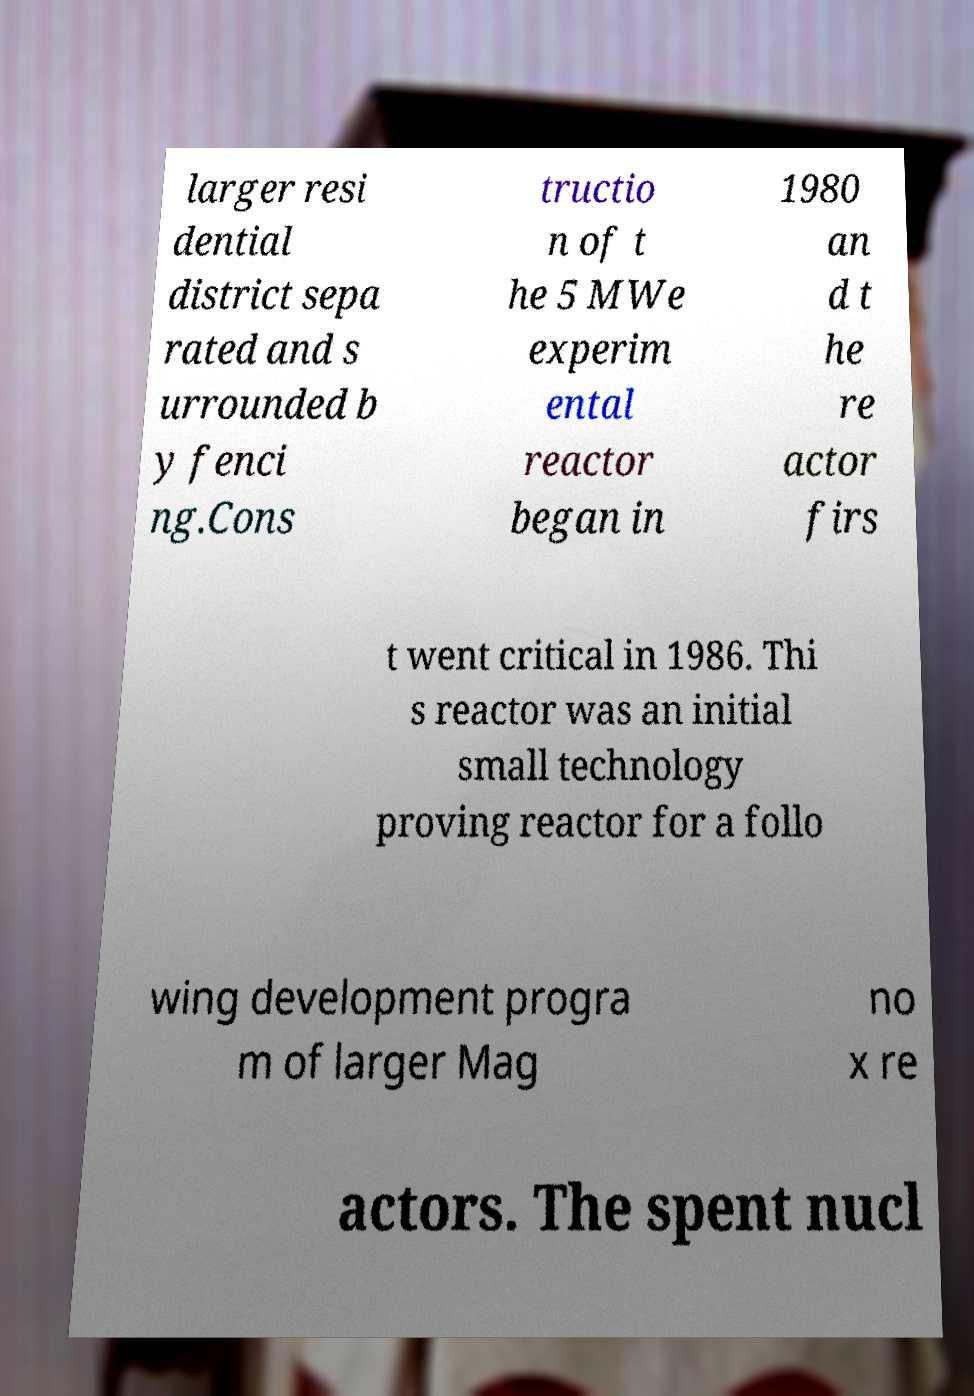Can you read and provide the text displayed in the image?This photo seems to have some interesting text. Can you extract and type it out for me? larger resi dential district sepa rated and s urrounded b y fenci ng.Cons tructio n of t he 5 MWe experim ental reactor began in 1980 an d t he re actor firs t went critical in 1986. Thi s reactor was an initial small technology proving reactor for a follo wing development progra m of larger Mag no x re actors. The spent nucl 